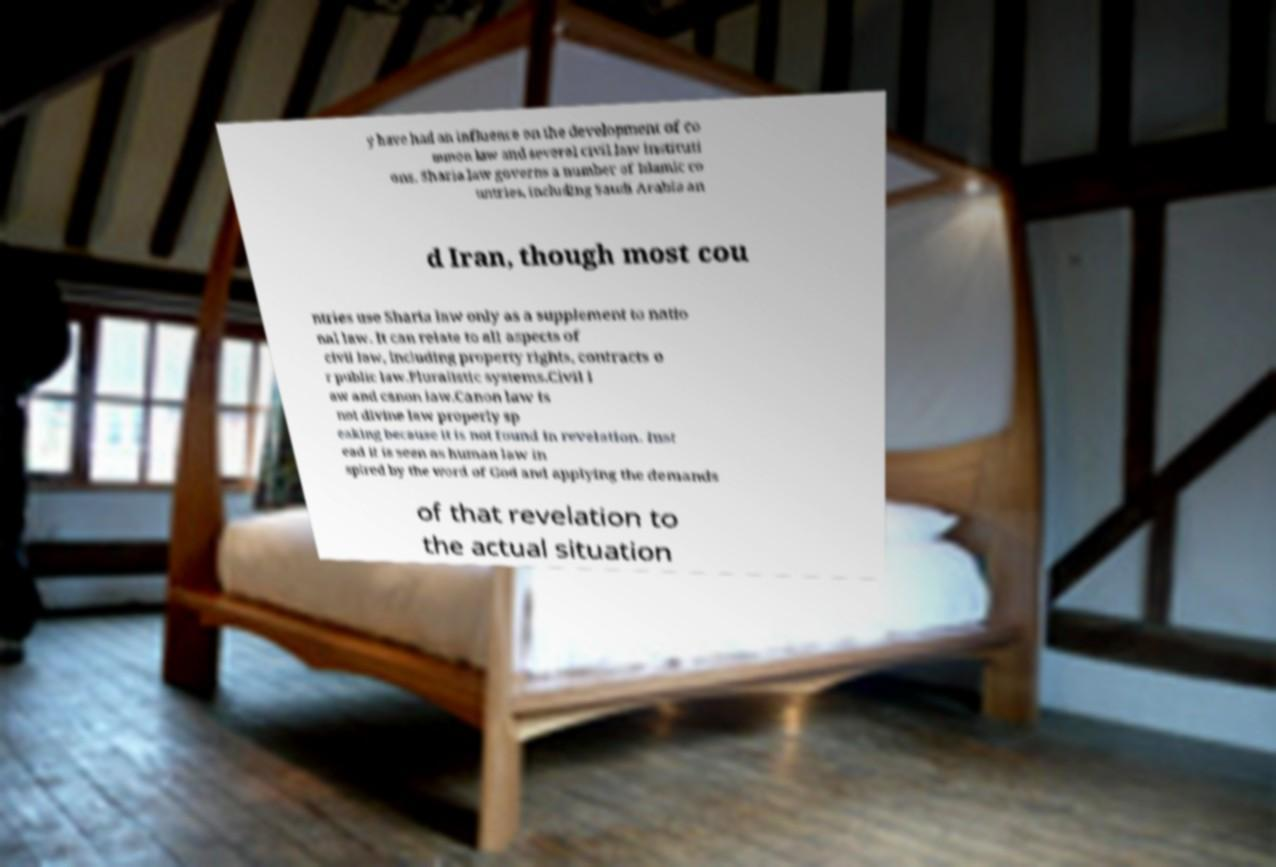What messages or text are displayed in this image? I need them in a readable, typed format. y have had an influence on the development of co mmon law and several civil law instituti ons. Sharia law governs a number of Islamic co untries, including Saudi Arabia an d Iran, though most cou ntries use Sharia law only as a supplement to natio nal law. It can relate to all aspects of civil law, including property rights, contracts o r public law.Pluralistic systems.Civil l aw and canon law.Canon law is not divine law properly sp eaking because it is not found in revelation. Inst ead it is seen as human law in spired by the word of God and applying the demands of that revelation to the actual situation 